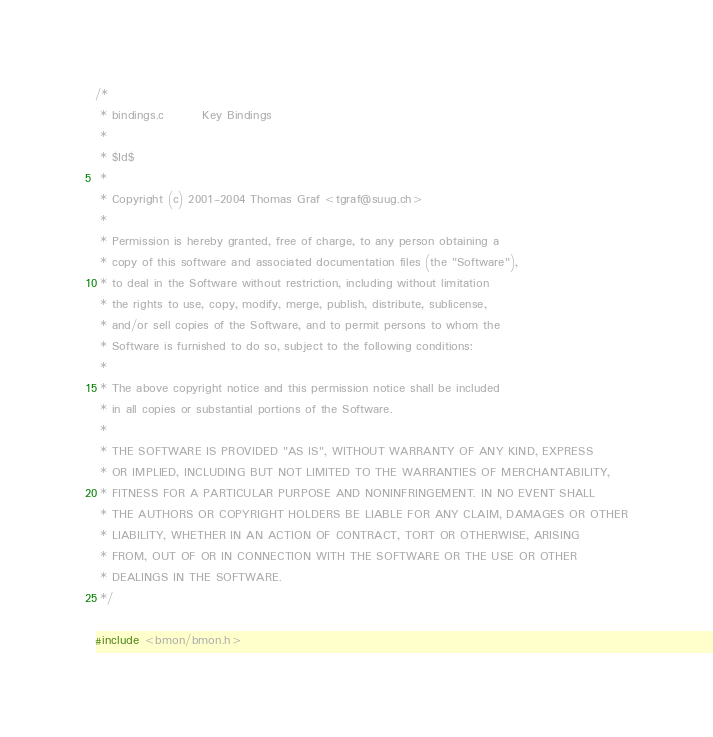<code> <loc_0><loc_0><loc_500><loc_500><_C_>/*
 * bindings.c        Key Bindings
 *
 * $Id$
 *
 * Copyright (c) 2001-2004 Thomas Graf <tgraf@suug.ch>
 *
 * Permission is hereby granted, free of charge, to any person obtaining a
 * copy of this software and associated documentation files (the "Software"),
 * to deal in the Software without restriction, including without limitation
 * the rights to use, copy, modify, merge, publish, distribute, sublicense,
 * and/or sell copies of the Software, and to permit persons to whom the
 * Software is furnished to do so, subject to the following conditions:
 *
 * The above copyright notice and this permission notice shall be included
 * in all copies or substantial portions of the Software.
 *
 * THE SOFTWARE IS PROVIDED "AS IS", WITHOUT WARRANTY OF ANY KIND, EXPRESS
 * OR IMPLIED, INCLUDING BUT NOT LIMITED TO THE WARRANTIES OF MERCHANTABILITY,
 * FITNESS FOR A PARTICULAR PURPOSE AND NONINFRINGEMENT. IN NO EVENT SHALL
 * THE AUTHORS OR COPYRIGHT HOLDERS BE LIABLE FOR ANY CLAIM, DAMAGES OR OTHER
 * LIABILITY, WHETHER IN AN ACTION OF CONTRACT, TORT OR OTHERWISE, ARISING
 * FROM, OUT OF OR IN CONNECTION WITH THE SOFTWARE OR THE USE OR OTHER
 * DEALINGS IN THE SOFTWARE.
 */

#include <bmon/bmon.h></code> 